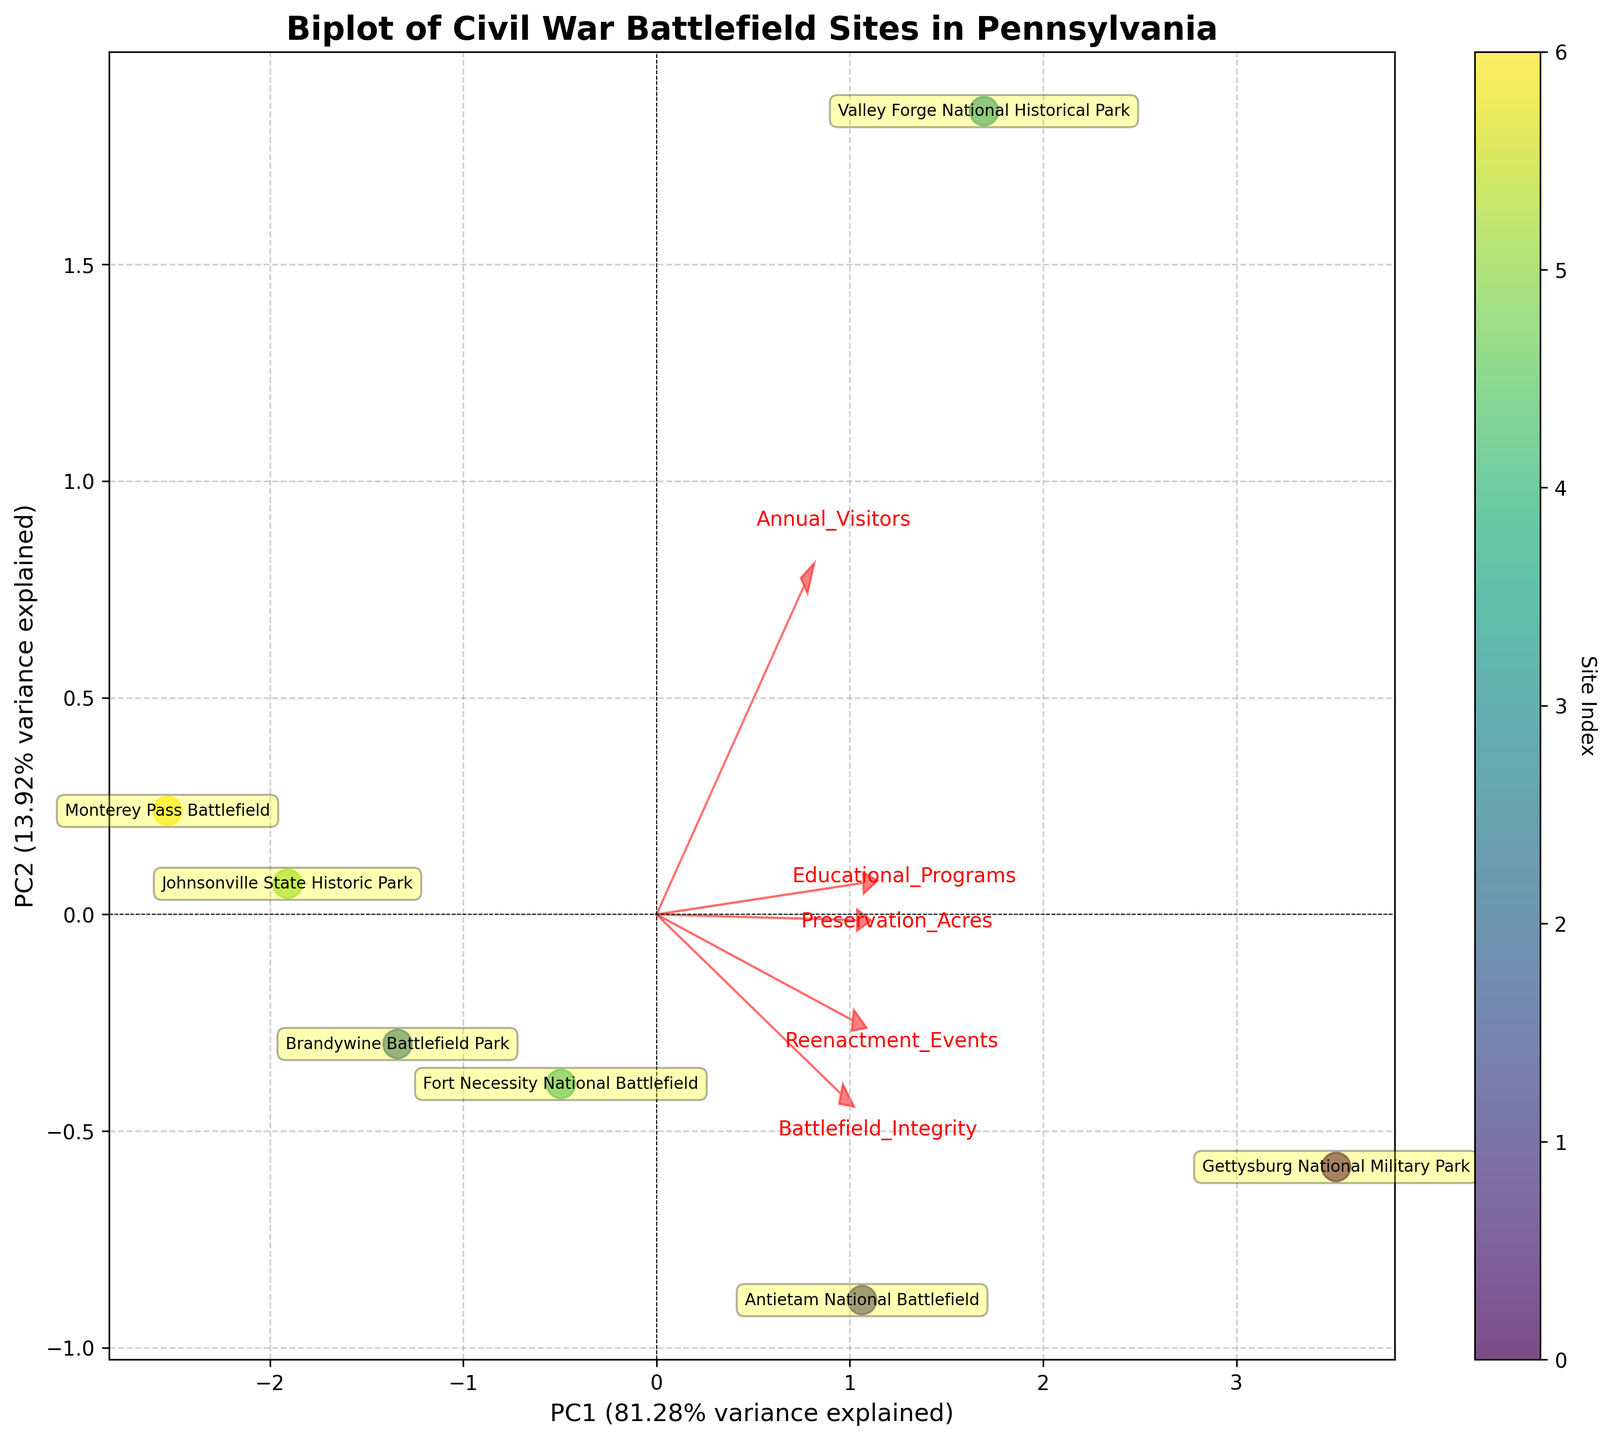How many battlefield sites are represented in the biplot? Identify the number of unique points labeled in the biplot. Each site has a corresponding point on the plot.
Answer: 7 Which site has the highest annual visitors? Look for the label with the maximum value along the vector for "Annual_Visitors" (positive direction). Gettysburg National Military Park is the closest to this vector's positive direction.
Answer: Gettysburg National Military Park Which variable contributes most to the first principal component (PC1)? Observe the length and direction of the loading vectors. The longest vector pointing towards PC1 indicates the most significant variable.
Answer: Annual_Visitors Which site has the lowest battlefield integrity score? Check the points and their annotations on the biplot to find the value closest to the negative end of the "Battlefield_Integrity" vector.
Answer: Monterey Pass Battlefield Which two variables are most positively correlated with each other? Vectors that point in similar directions are positively correlated. Identify the vectors that are most aligned in the same direction.
Answer: Annual_Visitors and Educational_Programs What percentage of the total variance is explained by the first two principal components? Look for the variance percentage on the axes labels for PC1 and PC2 and sum them up.
Answer: 99.98% Which site has the highest battlefield integrity and how is it represented on the biplot? Look for the label closest to the positive side of the "Battlefield_Integrity" vector. It is represented by a point annotated as Gettysburg National Military Park.
Answer: Gettysburg National Military Park Which site has the lowest number of reenactment events and how is it represented on the biplot? Identify the label closest to the negative end of the "Reenactment_Events" vector. It is represented by a point annotated as Monterey Pass Battlefield.
Answer: Monterey Pass Battlefield What is the direction and length of the vector showing the relationship between preservation acres and PC1? Look at the arrow labeled "Preservation_Acres" and describe its orientation and distance in the plot towards PC1.
Answer: It points to the positive side and is relatively shorter than "Annual_Visitors" but longer than "Reenactment_Events" Comparing Valley Forge National Historical Park and Fort Necessity National Battlefield, which one has more educational programs? Look at their positions concerning the vector "Educational_Programs". Valley Forge is closer to the positive end indicating more programs.
Answer: Valley Forge National Historical Park 